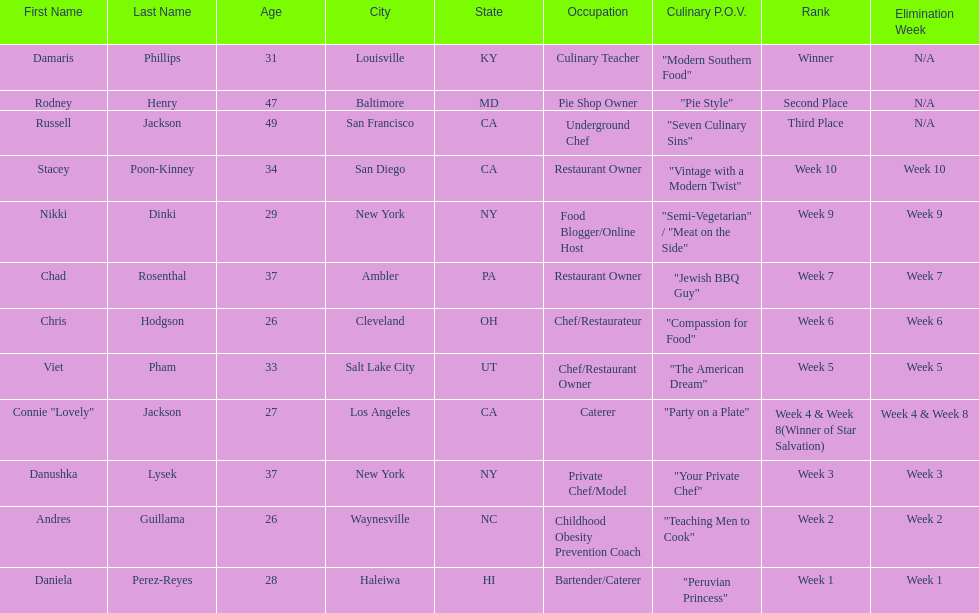Who was the first contestant to be eliminated on season 9 of food network star? Daniela Perez-Reyes. 